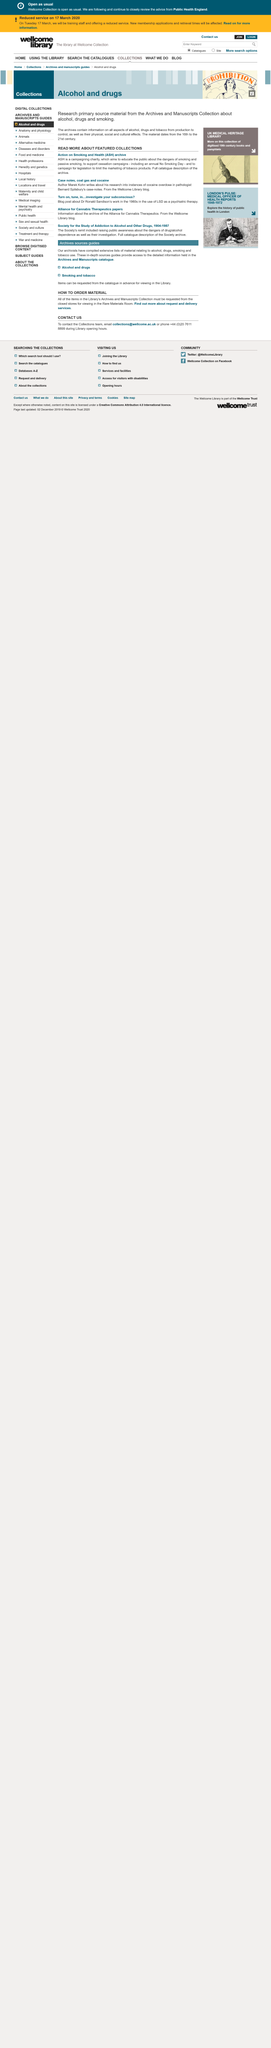List a handful of essential elements in this visual. Yes, ASH is a campaigning charity. Marek Kohn wrote about instances of cocaine overdose in his research. The abbreviation "ASH" stands for "Action on Smoking and Health. 